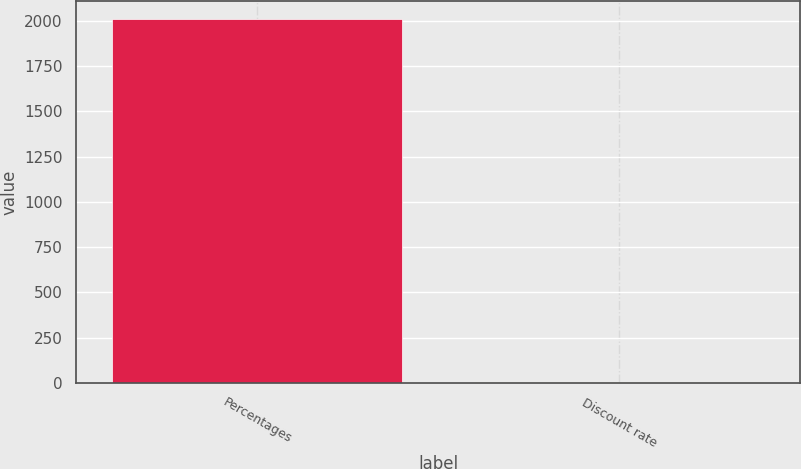<chart> <loc_0><loc_0><loc_500><loc_500><bar_chart><fcel>Percentages<fcel>Discount rate<nl><fcel>2008<fcel>6.5<nl></chart> 